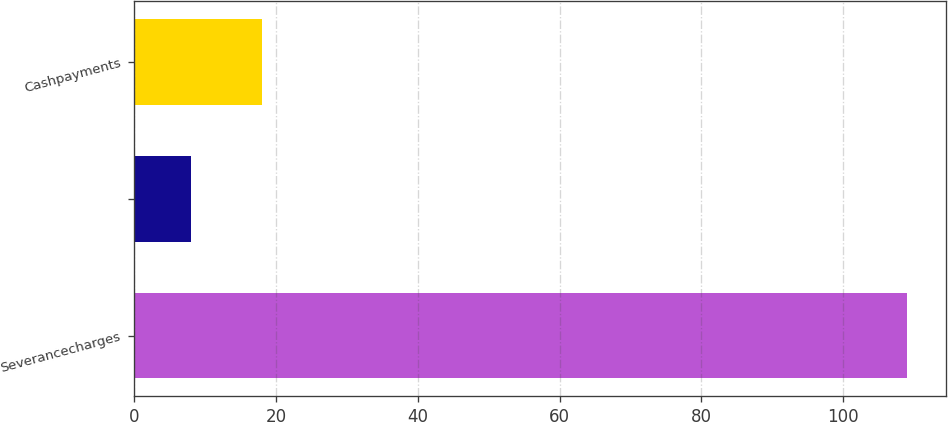<chart> <loc_0><loc_0><loc_500><loc_500><bar_chart><fcel>Severancecharges<fcel>Unnamed: 1<fcel>Cashpayments<nl><fcel>109<fcel>8<fcel>18.1<nl></chart> 